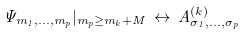<formula> <loc_0><loc_0><loc_500><loc_500>\Psi _ { m _ { 1 } , \dots , m _ { p } } | _ { m _ { p } \geq m _ { k } + M } \, \leftrightarrow \, A ^ { ( k ) } _ { \sigma _ { 1 } , \dots , \sigma _ { p } }</formula> 